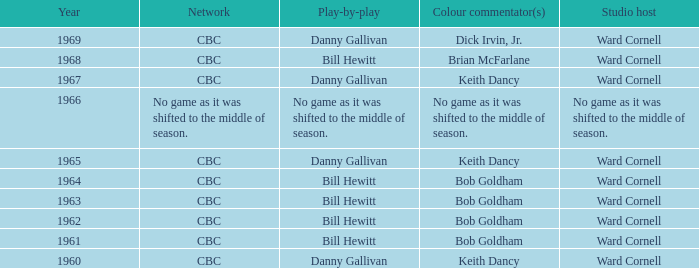Who did the play-by-play with studio host Ward Cornell and color commentator Bob Goldham? Bill Hewitt, Bill Hewitt, Bill Hewitt, Bill Hewitt. 